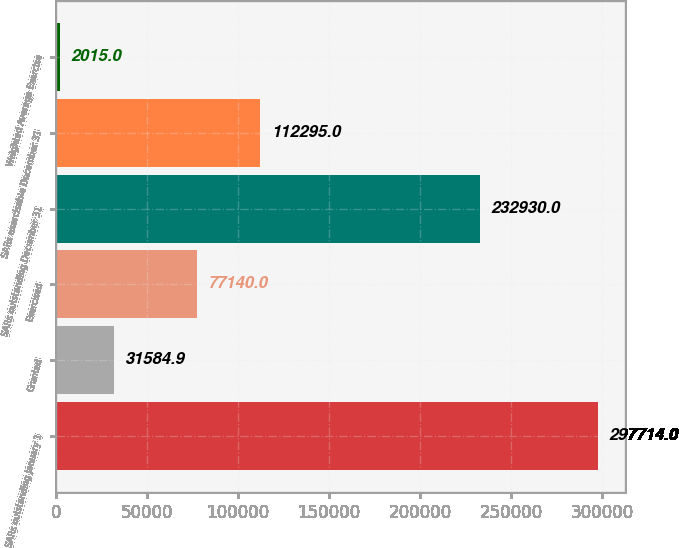Convert chart to OTSL. <chart><loc_0><loc_0><loc_500><loc_500><bar_chart><fcel>SARs outstanding January 1<fcel>Granted<fcel>Exercised<fcel>SARs outstanding December 31<fcel>SARs exercisable December 31<fcel>Weighted Average Exercise<nl><fcel>297714<fcel>31584.9<fcel>77140<fcel>232930<fcel>112295<fcel>2015<nl></chart> 